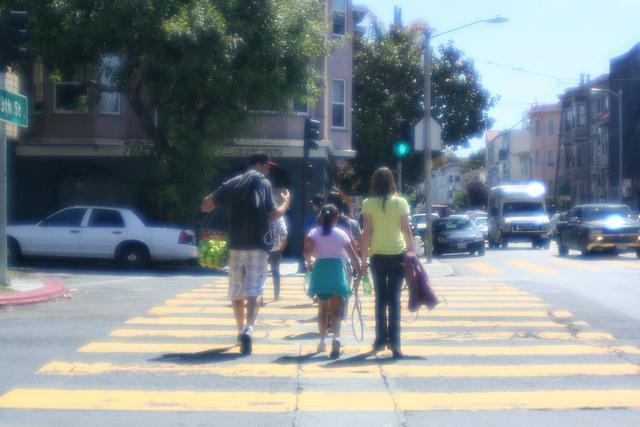How many people can be seen?
Choose the right answer and clarify with the format: 'Answer: answer
Rationale: rationale.'
Options: Three, four, six, five. Answer: six.
Rationale: There are 6. 